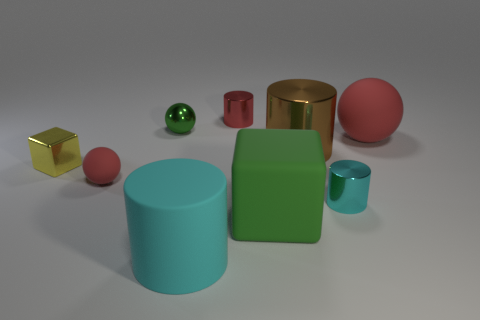Are any small shiny cylinders visible?
Make the answer very short. Yes. There is a yellow metallic thing; is its shape the same as the small red thing behind the big shiny cylinder?
Provide a succinct answer. No. There is a small sphere on the right side of the small red thing that is left of the cyan matte cylinder; what is its material?
Your answer should be compact. Metal. The big metallic thing is what color?
Offer a terse response. Brown. There is a metallic cylinder to the left of the large matte cube; does it have the same color as the rubber sphere that is on the right side of the large cyan object?
Ensure brevity in your answer.  Yes. There is a green matte object that is the same shape as the small yellow shiny object; what is its size?
Provide a short and direct response. Large. Is there a matte thing of the same color as the small metal ball?
Keep it short and to the point. Yes. What material is the other ball that is the same color as the big rubber ball?
Give a very brief answer. Rubber. How many other cylinders have the same color as the rubber cylinder?
Offer a terse response. 1. How many objects are either cylinders that are in front of the small yellow thing or brown metal cylinders?
Provide a succinct answer. 3. 